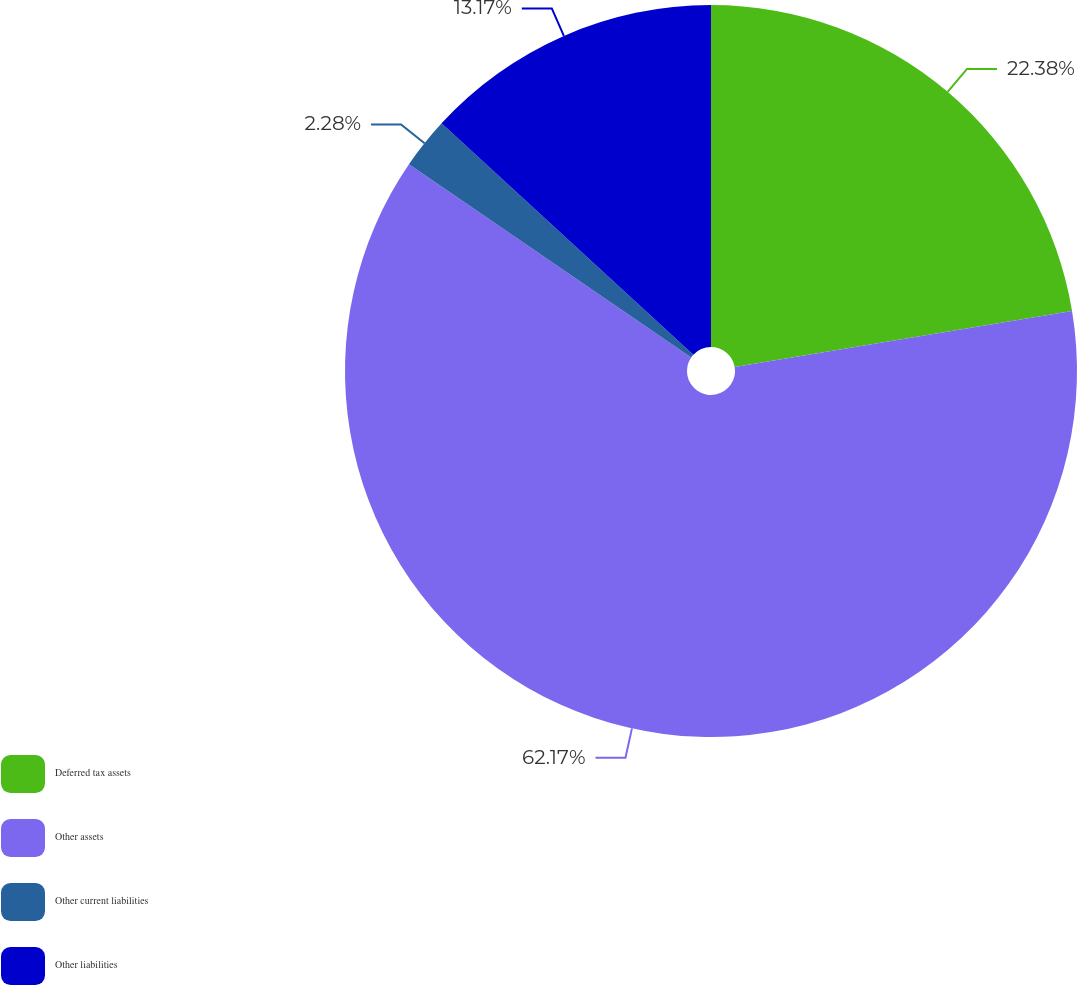Convert chart. <chart><loc_0><loc_0><loc_500><loc_500><pie_chart><fcel>Deferred tax assets<fcel>Other assets<fcel>Other current liabilities<fcel>Other liabilities<nl><fcel>22.38%<fcel>62.18%<fcel>2.28%<fcel>13.17%<nl></chart> 